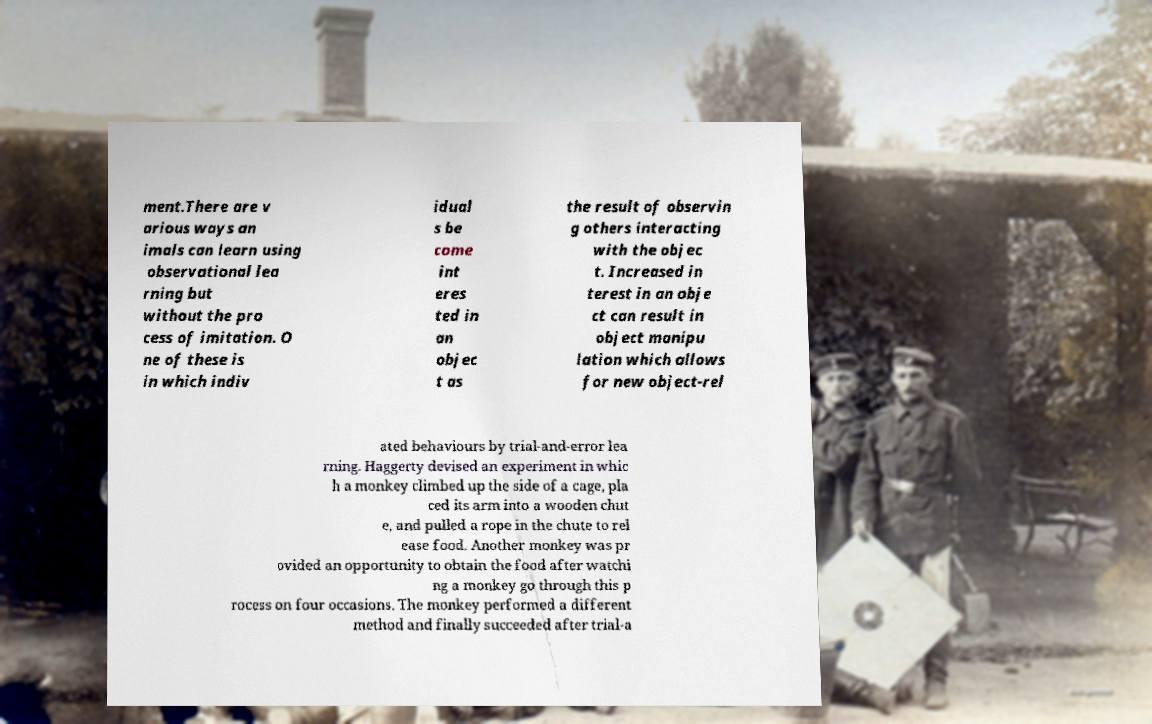Please read and relay the text visible in this image. What does it say? ment.There are v arious ways an imals can learn using observational lea rning but without the pro cess of imitation. O ne of these is in which indiv idual s be come int eres ted in an objec t as the result of observin g others interacting with the objec t. Increased in terest in an obje ct can result in object manipu lation which allows for new object-rel ated behaviours by trial-and-error lea rning. Haggerty devised an experiment in whic h a monkey climbed up the side of a cage, pla ced its arm into a wooden chut e, and pulled a rope in the chute to rel ease food. Another monkey was pr ovided an opportunity to obtain the food after watchi ng a monkey go through this p rocess on four occasions. The monkey performed a different method and finally succeeded after trial-a 